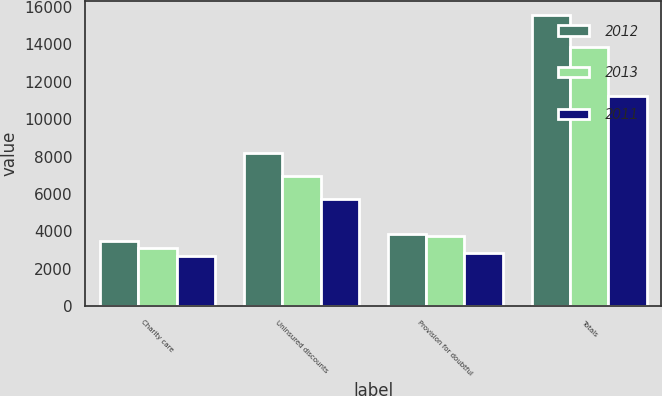Convert chart to OTSL. <chart><loc_0><loc_0><loc_500><loc_500><stacked_bar_chart><ecel><fcel>Charity care<fcel>Uninsured discounts<fcel>Provision for doubtful<fcel>Totals<nl><fcel>2012<fcel>3497<fcel>8210<fcel>3858<fcel>15565<nl><fcel>2013<fcel>3093<fcel>6978<fcel>3770<fcel>13841<nl><fcel>2011<fcel>2683<fcel>5707<fcel>2824<fcel>11214<nl></chart> 